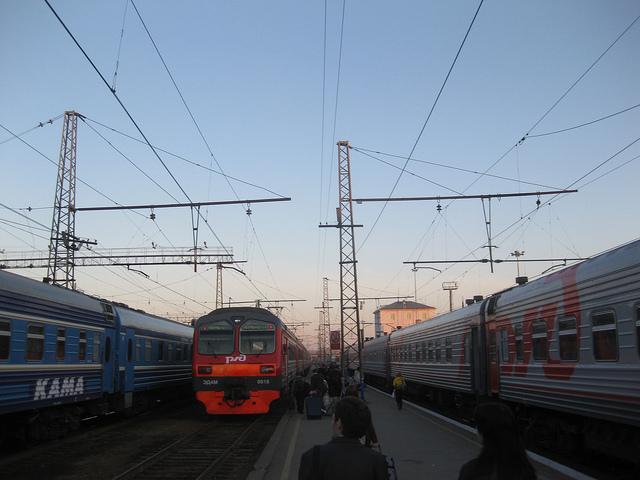How many trains are on the tracks?
Give a very brief answer. 3. How many people are there?
Give a very brief answer. 2. How many trains are there?
Give a very brief answer. 3. 